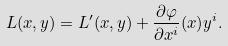<formula> <loc_0><loc_0><loc_500><loc_500>L ( x , y ) = L ^ { \prime } ( x , y ) + \frac { \partial \varphi } { \partial x ^ { i } } ( x ) y ^ { i } .</formula> 